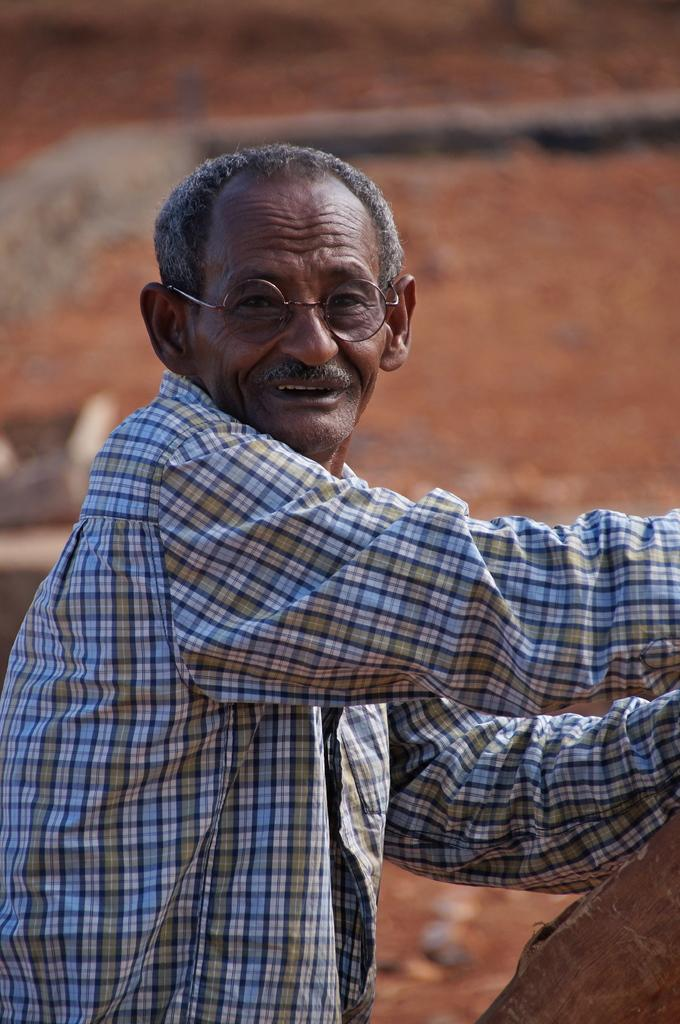Who is present in the image? There is a man in the picture. What is the man doing in the image? The man is standing. What is the man wearing on his upper body? The man is wearing a shirt. What accessory is the man wearing on his face? The man is wearing spectacles. What is the man's sister doing in the image? There is no mention of a sister in the image, so we cannot answer that question. 